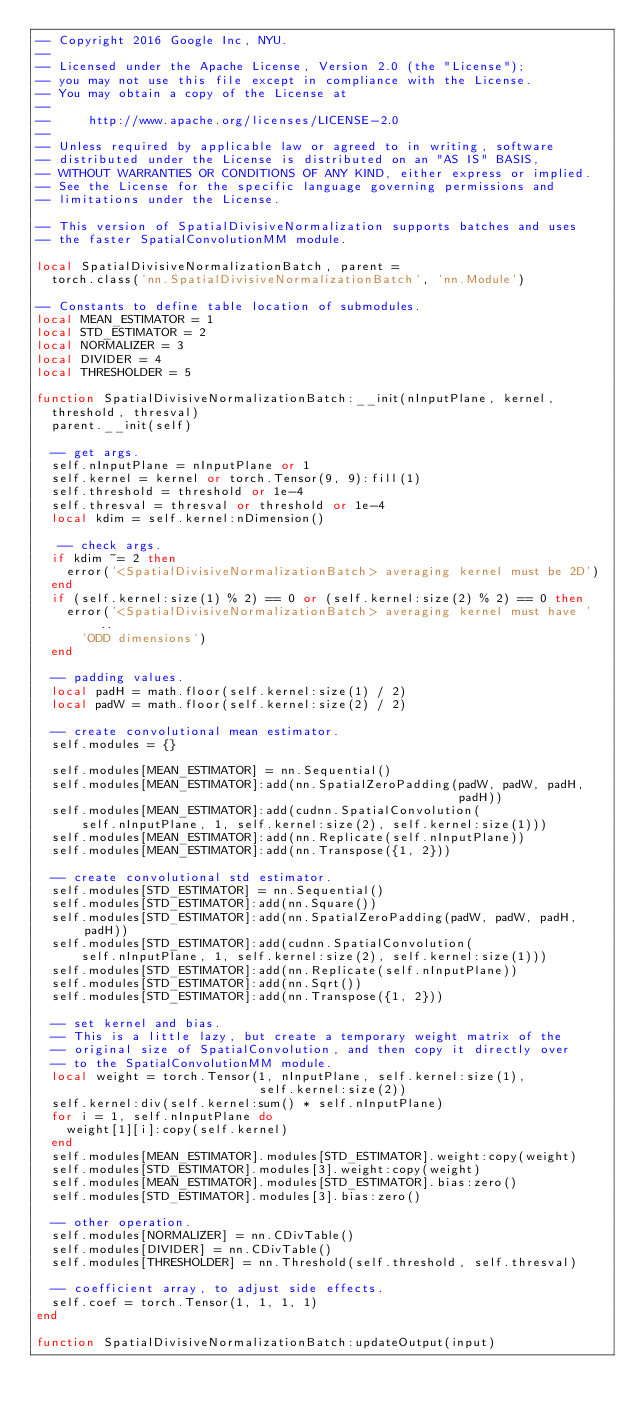<code> <loc_0><loc_0><loc_500><loc_500><_Lua_>-- Copyright 2016 Google Inc, NYU.
-- 
-- Licensed under the Apache License, Version 2.0 (the "License");
-- you may not use this file except in compliance with the License.
-- You may obtain a copy of the License at
-- 
--     http://www.apache.org/licenses/LICENSE-2.0
-- 
-- Unless required by applicable law or agreed to in writing, software
-- distributed under the License is distributed on an "AS IS" BASIS,
-- WITHOUT WARRANTIES OR CONDITIONS OF ANY KIND, either express or implied.
-- See the License for the specific language governing permissions and
-- limitations under the License.

-- This version of SpatialDivisiveNormalization supports batches and uses
-- the faster SpatialConvolutionMM module.

local SpatialDivisiveNormalizationBatch, parent =
  torch.class('nn.SpatialDivisiveNormalizationBatch', 'nn.Module')

-- Constants to define table location of submodules.
local MEAN_ESTIMATOR = 1
local STD_ESTIMATOR = 2
local NORMALIZER = 3
local DIVIDER = 4
local THRESHOLDER = 5

function SpatialDivisiveNormalizationBatch:__init(nInputPlane, kernel,
  threshold, thresval)
  parent.__init(self)

  -- get args.
  self.nInputPlane = nInputPlane or 1
  self.kernel = kernel or torch.Tensor(9, 9):fill(1)
  self.threshold = threshold or 1e-4
  self.thresval = thresval or threshold or 1e-4
  local kdim = self.kernel:nDimension()

   -- check args.
  if kdim ~= 2 then
    error('<SpatialDivisiveNormalizationBatch> averaging kernel must be 2D')
  end
  if (self.kernel:size(1) % 2) == 0 or (self.kernel:size(2) % 2) == 0 then
    error('<SpatialDivisiveNormalizationBatch> averaging kernel must have ' ..
      'ODD dimensions')
  end

  -- padding values.
  local padH = math.floor(self.kernel:size(1) / 2)
  local padW = math.floor(self.kernel:size(2) / 2)

  -- create convolutional mean estimator.
  self.modules = {}

  self.modules[MEAN_ESTIMATOR] = nn.Sequential()
  self.modules[MEAN_ESTIMATOR]:add(nn.SpatialZeroPadding(padW, padW, padH,
                                                         padH))
  self.modules[MEAN_ESTIMATOR]:add(cudnn.SpatialConvolution(
      self.nInputPlane, 1, self.kernel:size(2), self.kernel:size(1)))
  self.modules[MEAN_ESTIMATOR]:add(nn.Replicate(self.nInputPlane))
  self.modules[MEAN_ESTIMATOR]:add(nn.Transpose({1, 2}))

  -- create convolutional std estimator.
  self.modules[STD_ESTIMATOR] = nn.Sequential()
  self.modules[STD_ESTIMATOR]:add(nn.Square())
  self.modules[STD_ESTIMATOR]:add(nn.SpatialZeroPadding(padW, padW, padH, padH))
  self.modules[STD_ESTIMATOR]:add(cudnn.SpatialConvolution(
      self.nInputPlane, 1, self.kernel:size(2), self.kernel:size(1)))
  self.modules[STD_ESTIMATOR]:add(nn.Replicate(self.nInputPlane))
  self.modules[STD_ESTIMATOR]:add(nn.Sqrt())
  self.modules[STD_ESTIMATOR]:add(nn.Transpose({1, 2}))

  -- set kernel and bias.
  -- This is a little lazy, but create a temporary weight matrix of the
  -- original size of SpatialConvolution, and then copy it directly over
  -- to the SpatialConvolutionMM module.
  local weight = torch.Tensor(1, nInputPlane, self.kernel:size(1),
                              self.kernel:size(2))
  self.kernel:div(self.kernel:sum() * self.nInputPlane)
  for i = 1, self.nInputPlane do
    weight[1][i]:copy(self.kernel)
  end
  self.modules[MEAN_ESTIMATOR].modules[STD_ESTIMATOR].weight:copy(weight)
  self.modules[STD_ESTIMATOR].modules[3].weight:copy(weight)
  self.modules[MEAN_ESTIMATOR].modules[STD_ESTIMATOR].bias:zero()
  self.modules[STD_ESTIMATOR].modules[3].bias:zero()

  -- other operation.
  self.modules[NORMALIZER] = nn.CDivTable()
  self.modules[DIVIDER] = nn.CDivTable()
  self.modules[THRESHOLDER] = nn.Threshold(self.threshold, self.thresval)

  -- coefficient array, to adjust side effects.
  self.coef = torch.Tensor(1, 1, 1, 1)
end

function SpatialDivisiveNormalizationBatch:updateOutput(input)</code> 